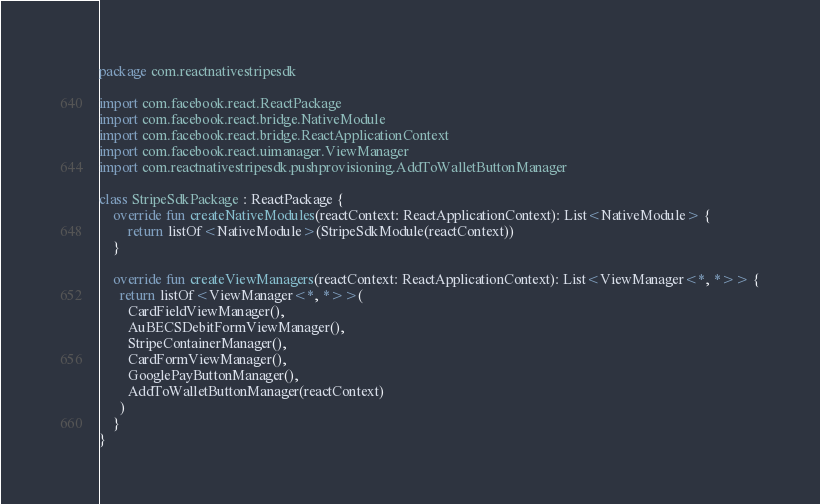Convert code to text. <code><loc_0><loc_0><loc_500><loc_500><_Kotlin_>package com.reactnativestripesdk

import com.facebook.react.ReactPackage
import com.facebook.react.bridge.NativeModule
import com.facebook.react.bridge.ReactApplicationContext
import com.facebook.react.uimanager.ViewManager
import com.reactnativestripesdk.pushprovisioning.AddToWalletButtonManager

class StripeSdkPackage : ReactPackage {
    override fun createNativeModules(reactContext: ReactApplicationContext): List<NativeModule> {
        return listOf<NativeModule>(StripeSdkModule(reactContext))
    }

    override fun createViewManagers(reactContext: ReactApplicationContext): List<ViewManager<*, *>> {
      return listOf<ViewManager<*, *>>(
        CardFieldViewManager(),
        AuBECSDebitFormViewManager(),
        StripeContainerManager(),
        CardFormViewManager(),
        GooglePayButtonManager(),
        AddToWalletButtonManager(reactContext)
      )
    }
}
</code> 